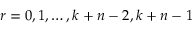Convert formula to latex. <formula><loc_0><loc_0><loc_500><loc_500>r = 0 , 1 , \dots , k + n - 2 , k + n - 1</formula> 